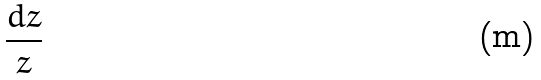Convert formula to latex. <formula><loc_0><loc_0><loc_500><loc_500>\frac { d z } { z }</formula> 